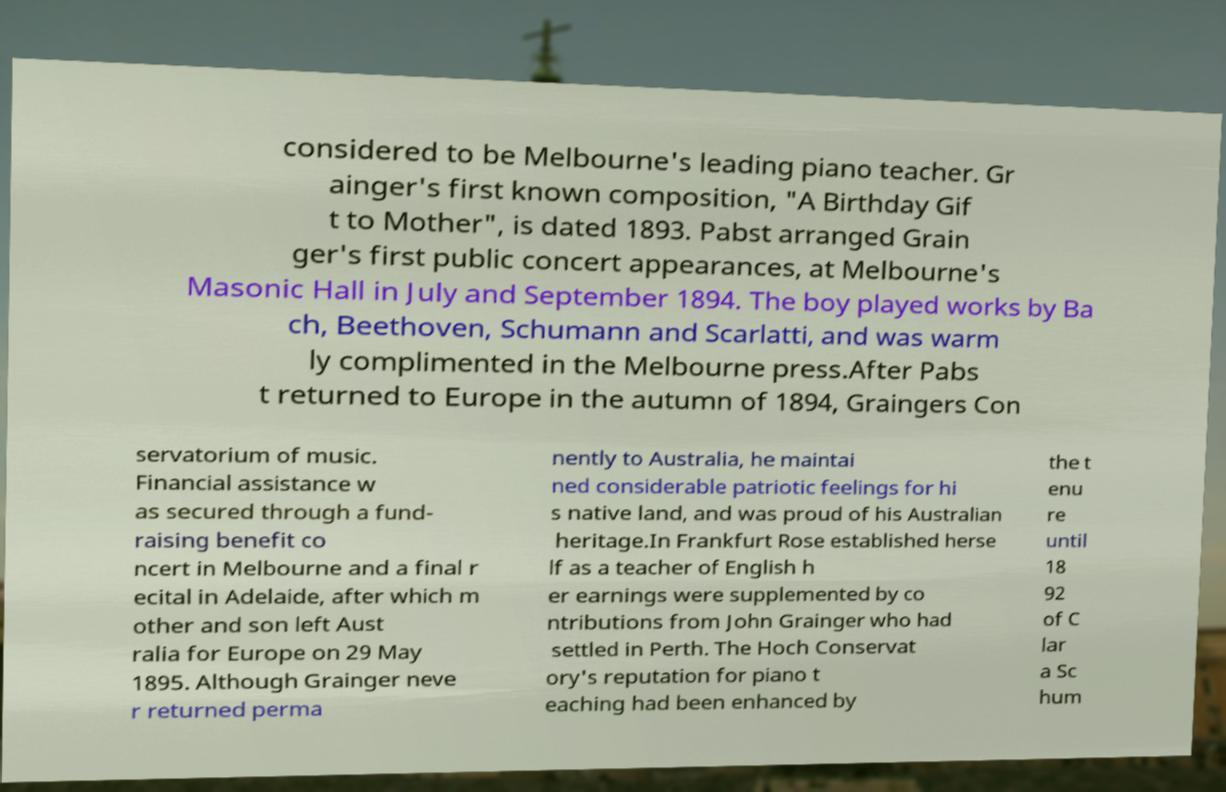Can you accurately transcribe the text from the provided image for me? considered to be Melbourne's leading piano teacher. Gr ainger's first known composition, "A Birthday Gif t to Mother", is dated 1893. Pabst arranged Grain ger's first public concert appearances, at Melbourne's Masonic Hall in July and September 1894. The boy played works by Ba ch, Beethoven, Schumann and Scarlatti, and was warm ly complimented in the Melbourne press.After Pabs t returned to Europe in the autumn of 1894, Graingers Con servatorium of music. Financial assistance w as secured through a fund- raising benefit co ncert in Melbourne and a final r ecital in Adelaide, after which m other and son left Aust ralia for Europe on 29 May 1895. Although Grainger neve r returned perma nently to Australia, he maintai ned considerable patriotic feelings for hi s native land, and was proud of his Australian heritage.In Frankfurt Rose established herse lf as a teacher of English h er earnings were supplemented by co ntributions from John Grainger who had settled in Perth. The Hoch Conservat ory's reputation for piano t eaching had been enhanced by the t enu re until 18 92 of C lar a Sc hum 